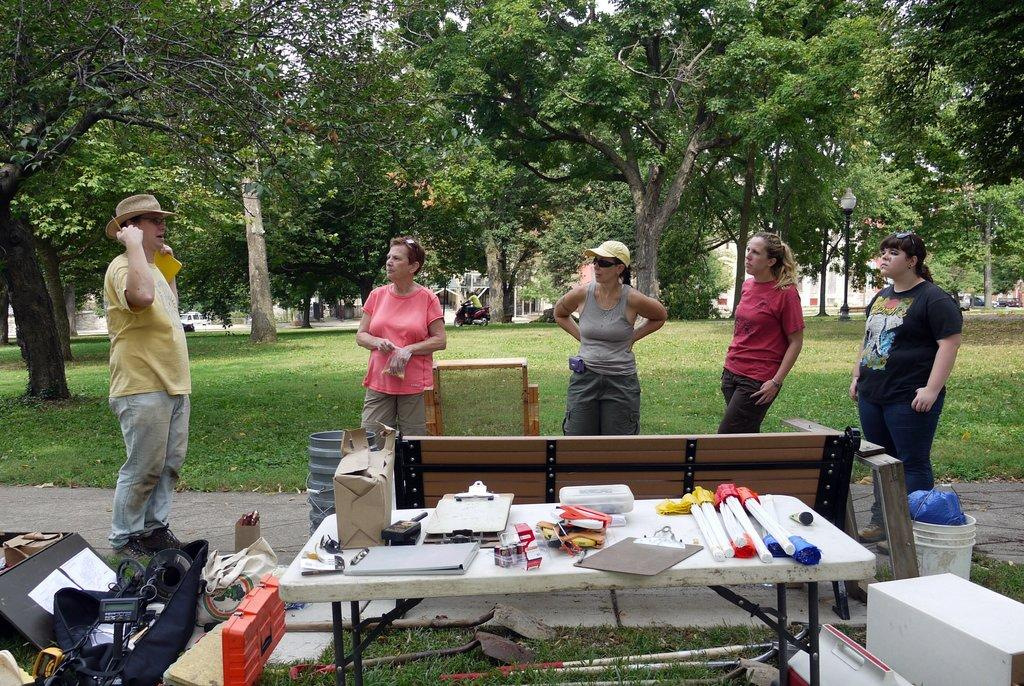How many people are present in the image? There are five persons in the image. What is one of the main objects in the image? There is a table in the image. Can you describe another object in the image? There is a bucket in the image. What might be used for writing in the image? There are writing pads in the image. What type of container can be seen in the image? There are boxes in the image. What might be used for support or construction in the image? There are rods in the image. What can be seen in the background of the image? There is grass, a bike, vehicles, poles, and trees in the background of the image. What type of pencil is being used by the person in the image? There is no pencil visible in the image. Can you describe the sound of the person coughing in the image? There is no coughing or any indication of a sound in the image. 